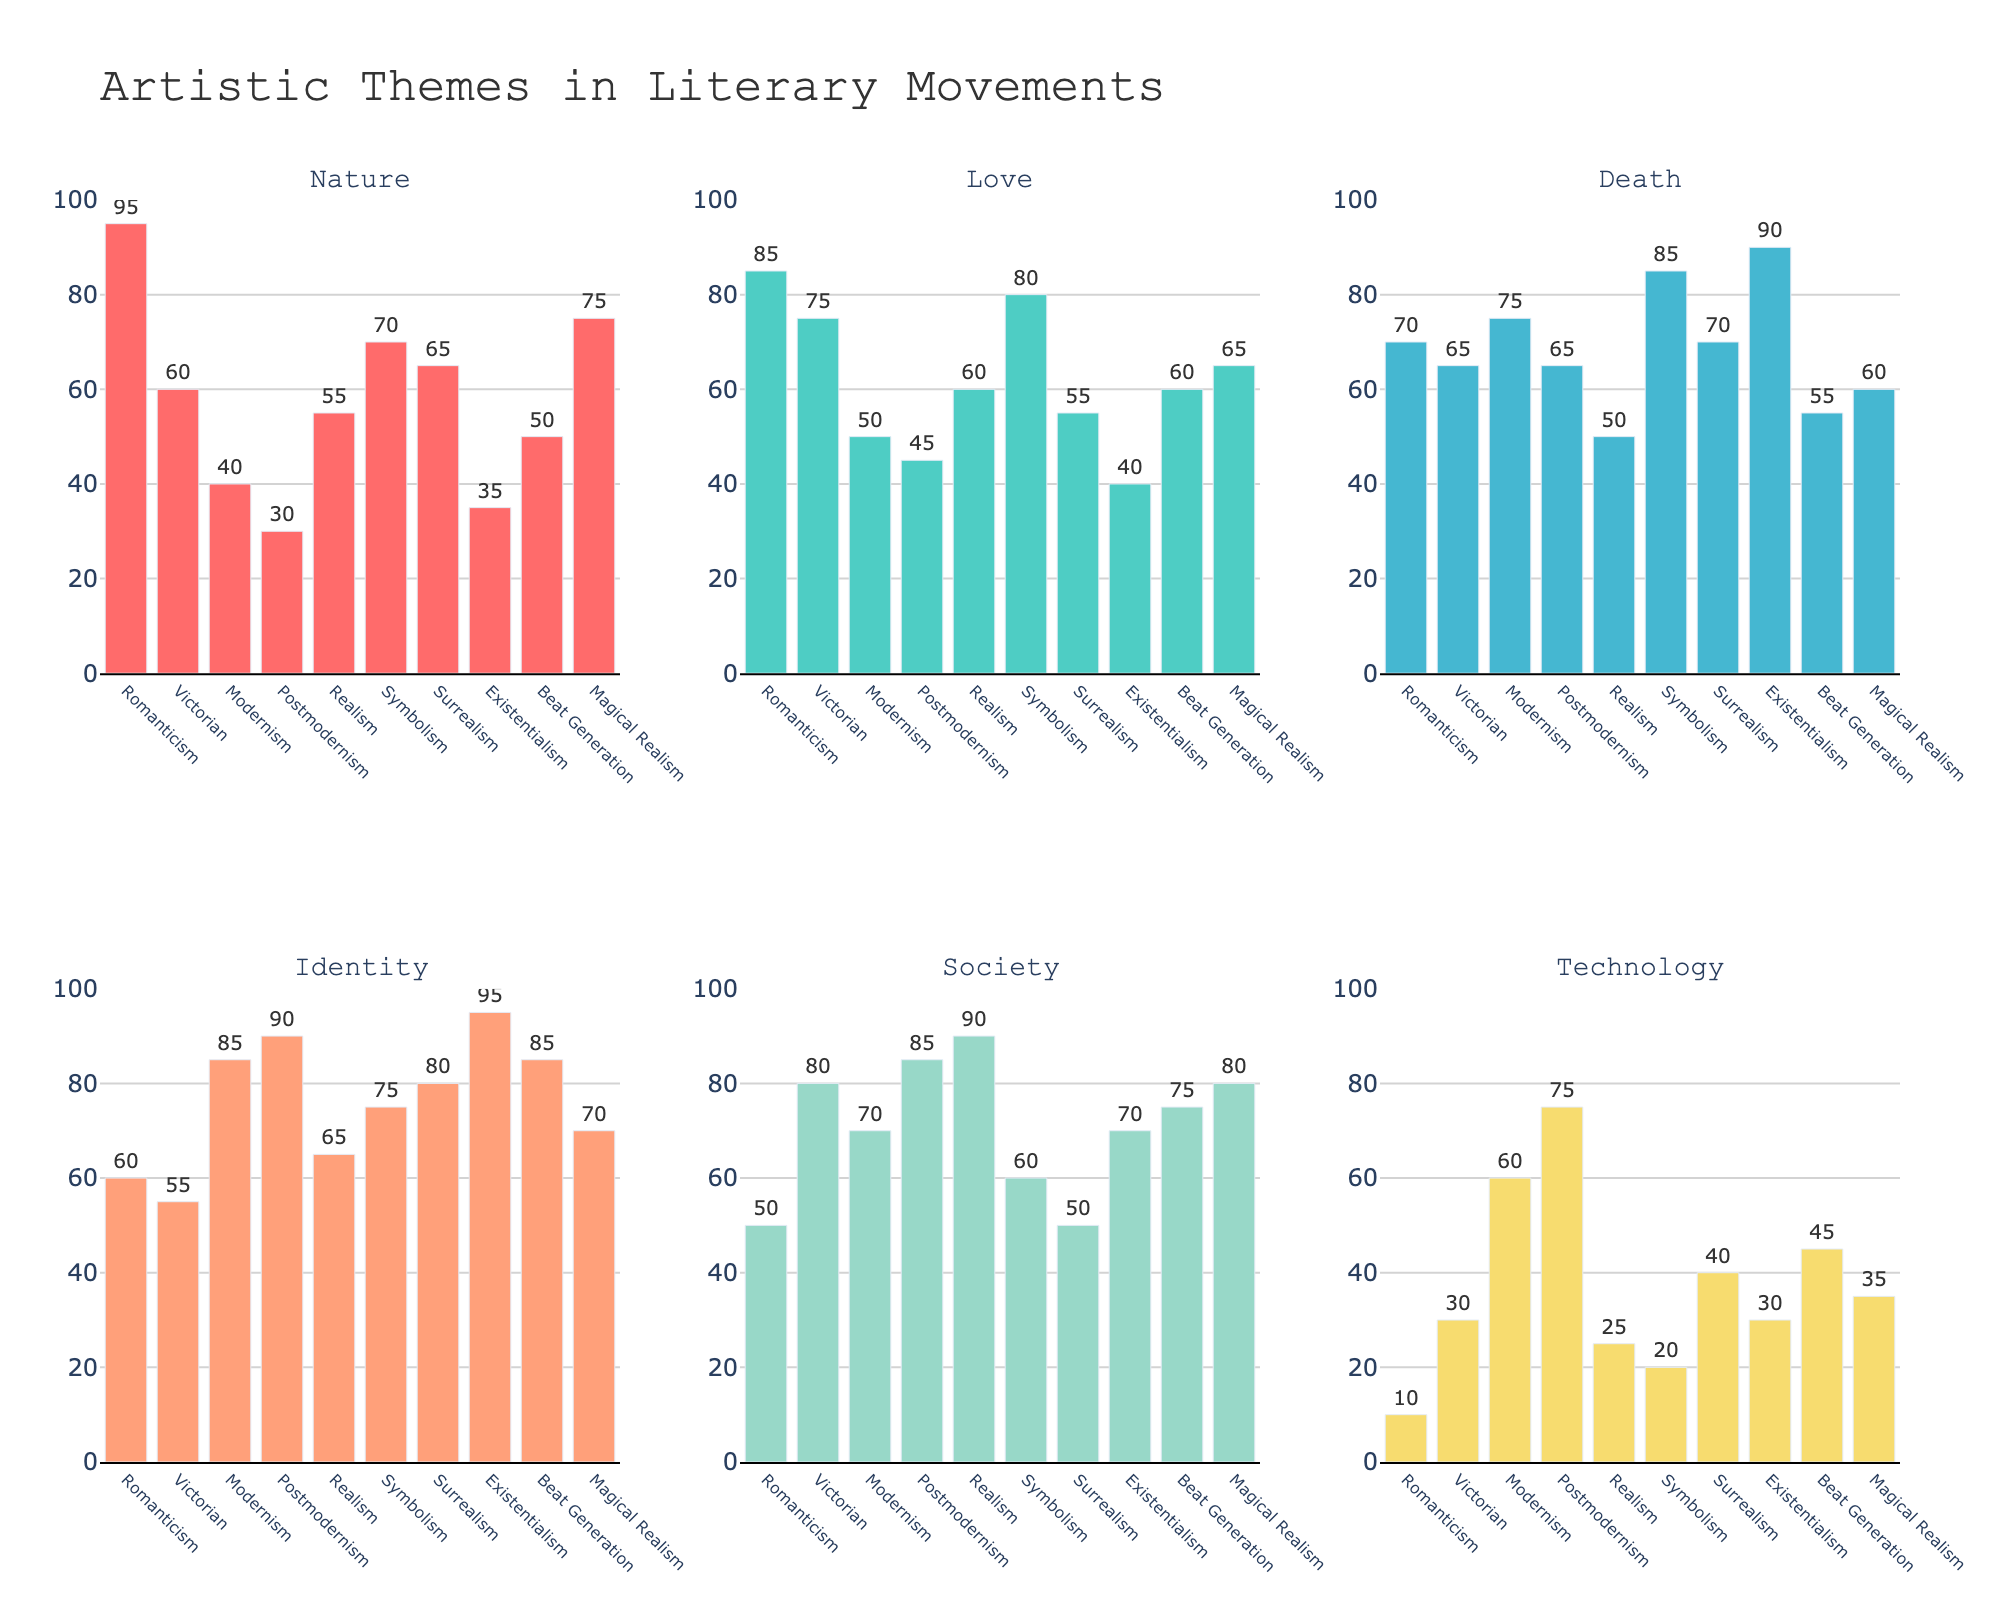Which literary movement features the highest frequency of the theme of Identity? To answer this, look at the bars representing the theme of Identity across all literary movements and identify the tallest bar. The tallest bar for Identity is in the Postmodernism subplot.
Answer: Postmodernism How many literary movements have a frequency of Love that is at least 60? Check the heights of the bars representing Love across all literary movements and count how many have values of 60 or higher. Romanticism, Victorian, Symbolism, Surrealism, and Magical Realism have Love frequencies of 60 or more, which sums to 5 movements.
Answer: 5 Which theme has the least presence in Beat Generation? To find this, compare the heights of all bars in the Beat Generation subplot and identify the shortest one. Technology is the shortest bar in the Beat Generation subplot at a frequency of 45.
Answer: Technology What is the combined frequency of Technology in Romanticism and Surrealism? Find the frequencies for Technology in Romanticism (10) and Surrealism (40), then add them together. 10 + 40 = 50
Answer: 50 Which theme is consistently depicted more in Modernism than in Realism? Compare the bar heights for each theme between Modernism and Realism. Identity, Technology, and Death in Modernism have higher values compared to Realism.
Answer: Identity, Technology, Death What is the average frequency of the theme of Death across all literary movements? Add up the frequencies of Death for all movements and divide by the number of movements. (70+65+75+65+50+85+70+90+55+60)/10 = 68.5
Answer: 68.5 Does Victorian literature depict the theme of Society more frequently than the theme of Technology in Symbolism? Compare the heights of the Society bar in Victorian literature (80) with Technology in Symbolism (20). Society in Victorian is indeed higher.
Answer: Yes What is the frequency range for the theme of Nature across all movements? Identify the maximum and minimum frequencies of Nature. The highest is 95 (Romanticism) and the lowest is 30 (Postmodernism). The range is 95 - 30 = 65.
Answer: 65 Which literary movement has the least frequency of the themes of Love and Nature combined? Calculate the combined frequencies for Love and Nature in each movement, then identify the smallest sum. The combined frequency for Postmodernism is 30 (Nature) + 45 (Love) = 75, which is the smallest sum among all movements.
Answer: Postmodernism In which movement does Technology show the greatest increase compared to Nature? Check the difference between Technology and Nature for each movement and identify the largest positive difference. For Postmodernism, Technology (75) - Nature (30) = 45, indicating the greatest increase.
Answer: Postmodernism 